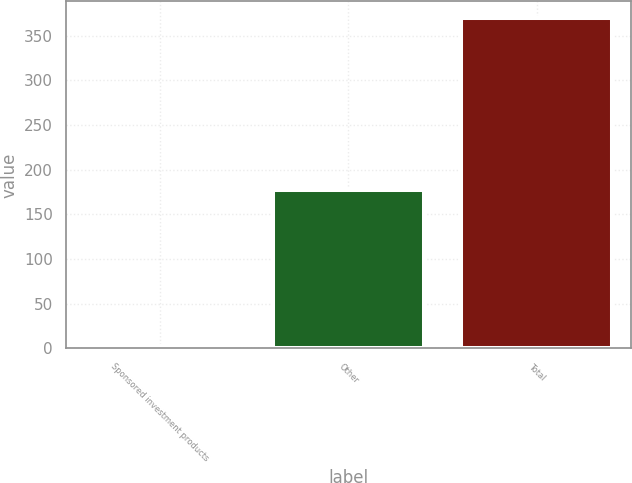Convert chart. <chart><loc_0><loc_0><loc_500><loc_500><bar_chart><fcel>Sponsored investment products<fcel>Other<fcel>Total<nl><fcel>3<fcel>177<fcel>370<nl></chart> 